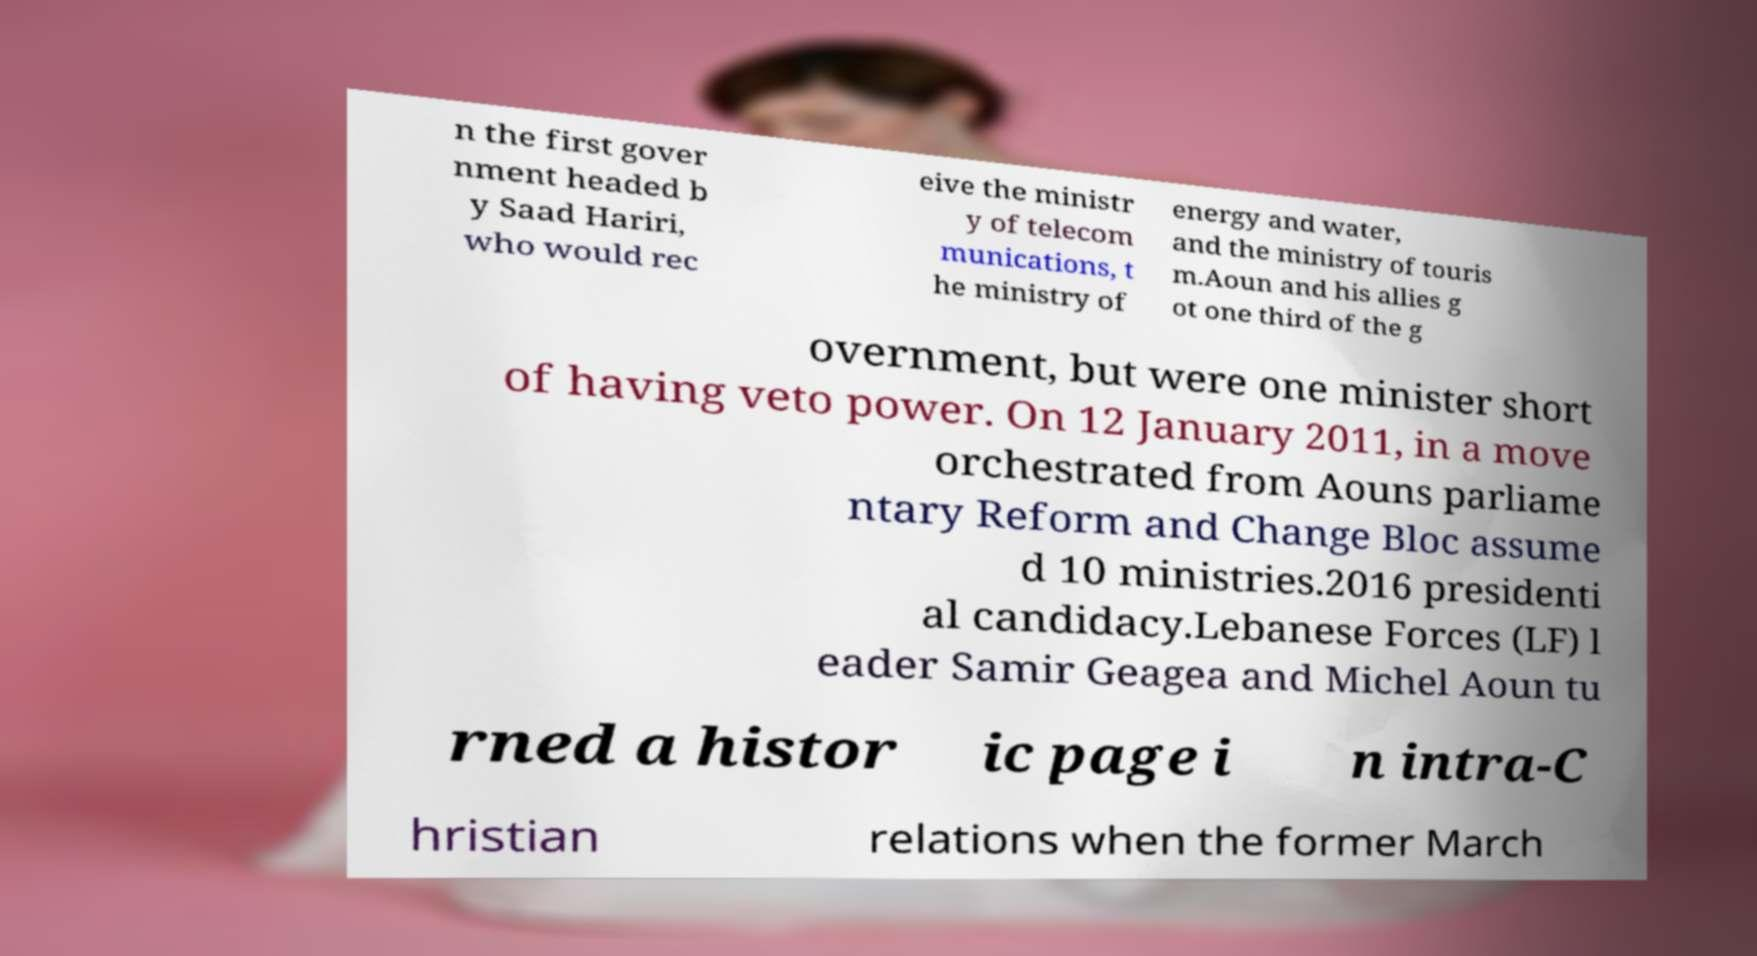Can you read and provide the text displayed in the image?This photo seems to have some interesting text. Can you extract and type it out for me? n the first gover nment headed b y Saad Hariri, who would rec eive the ministr y of telecom munications, t he ministry of energy and water, and the ministry of touris m.Aoun and his allies g ot one third of the g overnment, but were one minister short of having veto power. On 12 January 2011, in a move orchestrated from Aouns parliame ntary Reform and Change Bloc assume d 10 ministries.2016 presidenti al candidacy.Lebanese Forces (LF) l eader Samir Geagea and Michel Aoun tu rned a histor ic page i n intra-C hristian relations when the former March 